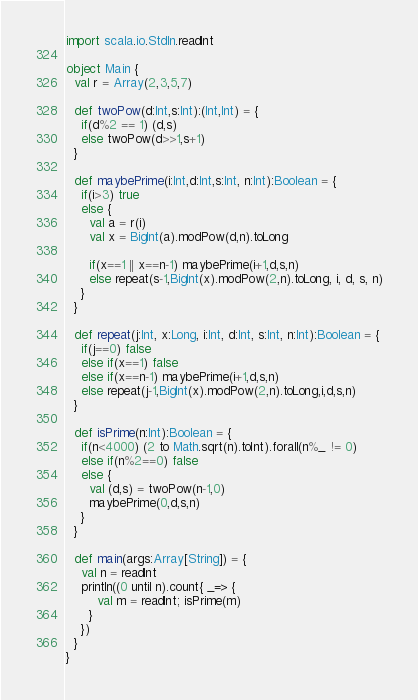Convert code to text. <code><loc_0><loc_0><loc_500><loc_500><_Scala_>import scala.io.StdIn.readInt

object Main {
  val r = Array(2,3,5,7)

  def twoPow(d:Int,s:Int):(Int,Int) = {
    if(d%2 == 1) (d,s)
    else twoPow(d>>1,s+1)
  }

  def maybePrime(i:Int,d:Int,s:Int, n:Int):Boolean = {
    if(i>3) true
    else {
      val a = r(i)
      val x = BigInt(a).modPow(d,n).toLong

      if(x==1 || x==n-1) maybePrime(i+1,d,s,n)
      else repeat(s-1,BigInt(x).modPow(2,n).toLong, i, d, s, n)
    }
  }

  def repeat(j:Int, x:Long, i:Int, d:Int, s:Int, n:Int):Boolean = {
    if(j==0) false
    else if(x==1) false
    else if(x==n-1) maybePrime(i+1,d,s,n)
    else repeat(j-1,BigInt(x).modPow(2,n).toLong,i,d,s,n)
  }

  def isPrime(n:Int):Boolean = {
    if(n<4000) (2 to Math.sqrt(n).toInt).forall(n%_ != 0)
    else if(n%2==0) false
    else {
      val (d,s) = twoPow(n-1,0)
      maybePrime(0,d,s,n)
    }
  }

  def main(args:Array[String]) = {
    val n = readInt
    println((0 until n).count{ _=> {
        val m = readInt; isPrime(m)
      }
    })
  }
}</code> 